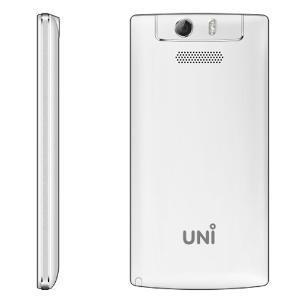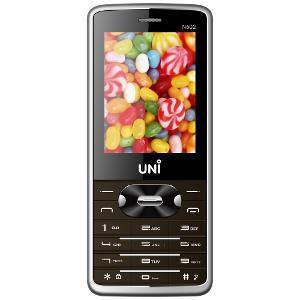The first image is the image on the left, the second image is the image on the right. For the images shown, is this caption "The left image shows a side-view of a white phone on the left of a back view of a white phone." true? Answer yes or no. Yes. 